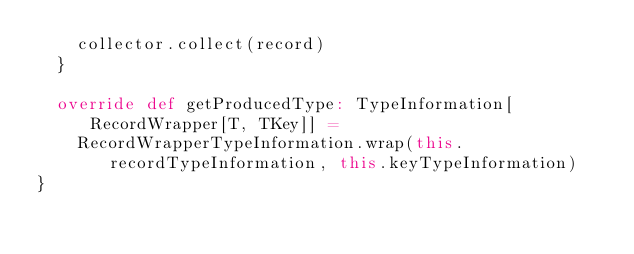<code> <loc_0><loc_0><loc_500><loc_500><_Scala_>    collector.collect(record)
  }

  override def getProducedType: TypeInformation[RecordWrapper[T, TKey]] =
    RecordWrapperTypeInformation.wrap(this.recordTypeInformation, this.keyTypeInformation)
}
</code> 